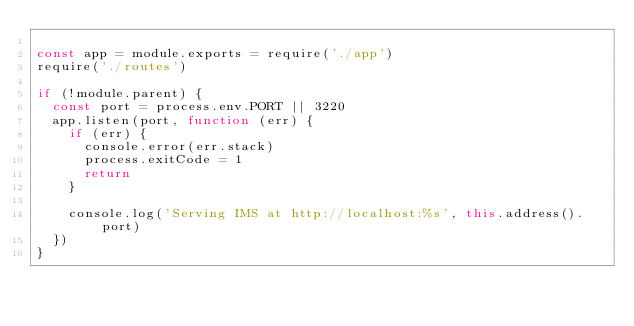Convert code to text. <code><loc_0><loc_0><loc_500><loc_500><_JavaScript_>
const app = module.exports = require('./app')
require('./routes')

if (!module.parent) {
  const port = process.env.PORT || 3220
  app.listen(port, function (err) {
    if (err) {
      console.error(err.stack)
      process.exitCode = 1
      return
    }

    console.log('Serving IMS at http://localhost:%s', this.address().port)
  })
}
</code> 